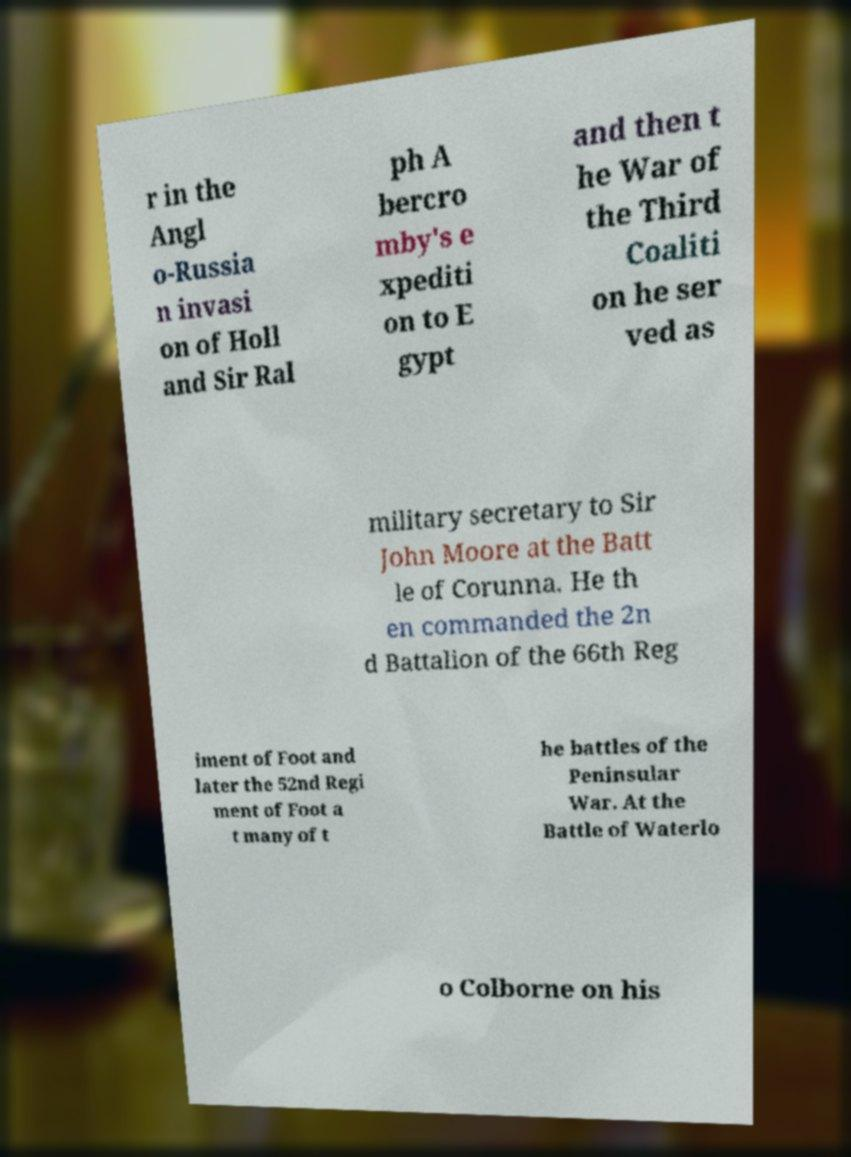There's text embedded in this image that I need extracted. Can you transcribe it verbatim? r in the Angl o-Russia n invasi on of Holl and Sir Ral ph A bercro mby's e xpediti on to E gypt and then t he War of the Third Coaliti on he ser ved as military secretary to Sir John Moore at the Batt le of Corunna. He th en commanded the 2n d Battalion of the 66th Reg iment of Foot and later the 52nd Regi ment of Foot a t many of t he battles of the Peninsular War. At the Battle of Waterlo o Colborne on his 